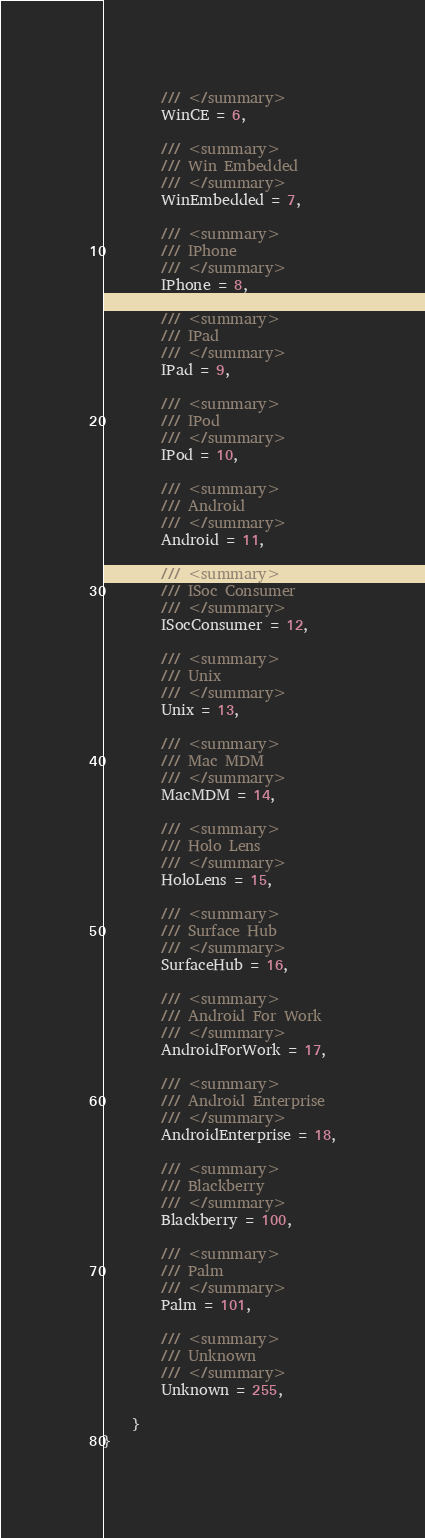<code> <loc_0><loc_0><loc_500><loc_500><_C#_>        /// </summary>
        WinCE = 6,
	
        /// <summary>
        /// Win Embedded
        /// </summary>
        WinEmbedded = 7,
	
        /// <summary>
        /// IPhone
        /// </summary>
        IPhone = 8,
	
        /// <summary>
        /// IPad
        /// </summary>
        IPad = 9,
	
        /// <summary>
        /// IPod
        /// </summary>
        IPod = 10,
	
        /// <summary>
        /// Android
        /// </summary>
        Android = 11,
	
        /// <summary>
        /// ISoc Consumer
        /// </summary>
        ISocConsumer = 12,
	
        /// <summary>
        /// Unix
        /// </summary>
        Unix = 13,
	
        /// <summary>
        /// Mac MDM
        /// </summary>
        MacMDM = 14,
	
        /// <summary>
        /// Holo Lens
        /// </summary>
        HoloLens = 15,
	
        /// <summary>
        /// Surface Hub
        /// </summary>
        SurfaceHub = 16,
	
        /// <summary>
        /// Android For Work
        /// </summary>
        AndroidForWork = 17,
	
        /// <summary>
        /// Android Enterprise
        /// </summary>
        AndroidEnterprise = 18,
	
        /// <summary>
        /// Blackberry
        /// </summary>
        Blackberry = 100,
	
        /// <summary>
        /// Palm
        /// </summary>
        Palm = 101,
	
        /// <summary>
        /// Unknown
        /// </summary>
        Unknown = 255,
	
    }
}
</code> 